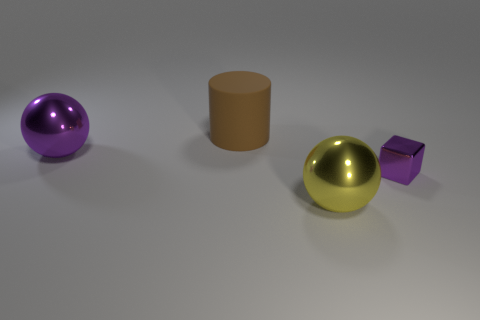Add 4 large rubber cylinders. How many objects exist? 8 Subtract all cylinders. How many objects are left? 3 Subtract 0 green cylinders. How many objects are left? 4 Subtract all large cylinders. Subtract all tiny purple metallic objects. How many objects are left? 2 Add 4 big yellow metal spheres. How many big yellow metal spheres are left? 5 Add 4 matte things. How many matte things exist? 5 